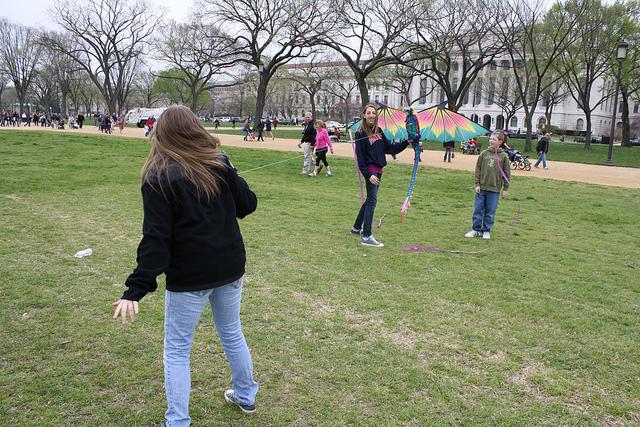What are they doing in the park?
Concise answer only. Flying kite. Which season is this?
Short answer required. Fall. What activity is the woman in this picture engaged in?
Quick response, please. Kite flying. Is the day cool?
Be succinct. Yes. 